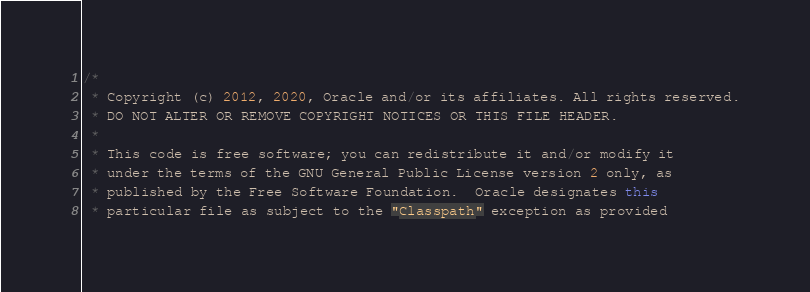<code> <loc_0><loc_0><loc_500><loc_500><_Java_>/*
 * Copyright (c) 2012, 2020, Oracle and/or its affiliates. All rights reserved.
 * DO NOT ALTER OR REMOVE COPYRIGHT NOTICES OR THIS FILE HEADER.
 *
 * This code is free software; you can redistribute it and/or modify it
 * under the terms of the GNU General Public License version 2 only, as
 * published by the Free Software Foundation.  Oracle designates this
 * particular file as subject to the "Classpath" exception as provided</code> 